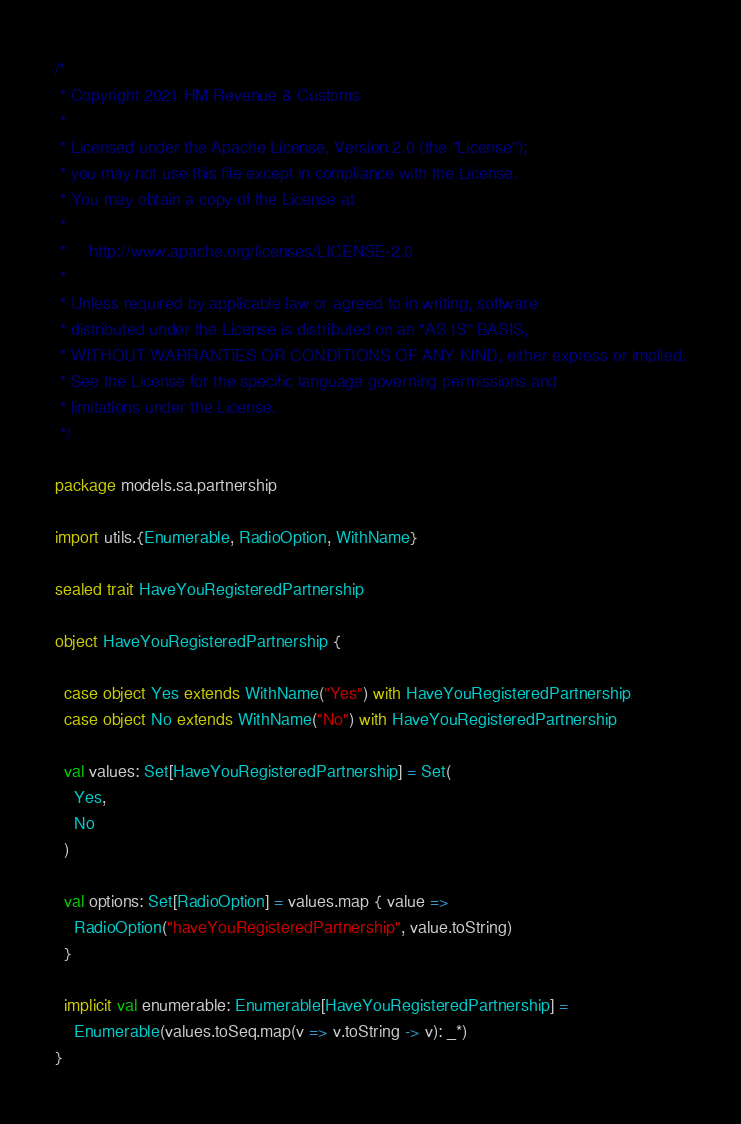Convert code to text. <code><loc_0><loc_0><loc_500><loc_500><_Scala_>/*
 * Copyright 2021 HM Revenue & Customs
 *
 * Licensed under the Apache License, Version 2.0 (the "License");
 * you may not use this file except in compliance with the License.
 * You may obtain a copy of the License at
 *
 *     http://www.apache.org/licenses/LICENSE-2.0
 *
 * Unless required by applicable law or agreed to in writing, software
 * distributed under the License is distributed on an "AS IS" BASIS,
 * WITHOUT WARRANTIES OR CONDITIONS OF ANY KIND, either express or implied.
 * See the License for the specific language governing permissions and
 * limitations under the License.
 */

package models.sa.partnership

import utils.{Enumerable, RadioOption, WithName}

sealed trait HaveYouRegisteredPartnership

object HaveYouRegisteredPartnership {

  case object Yes extends WithName("Yes") with HaveYouRegisteredPartnership
  case object No extends WithName("No") with HaveYouRegisteredPartnership

  val values: Set[HaveYouRegisteredPartnership] = Set(
    Yes,
    No
  )

  val options: Set[RadioOption] = values.map { value =>
    RadioOption("haveYouRegisteredPartnership", value.toString)
  }

  implicit val enumerable: Enumerable[HaveYouRegisteredPartnership] =
    Enumerable(values.toSeq.map(v => v.toString -> v): _*)
}
</code> 